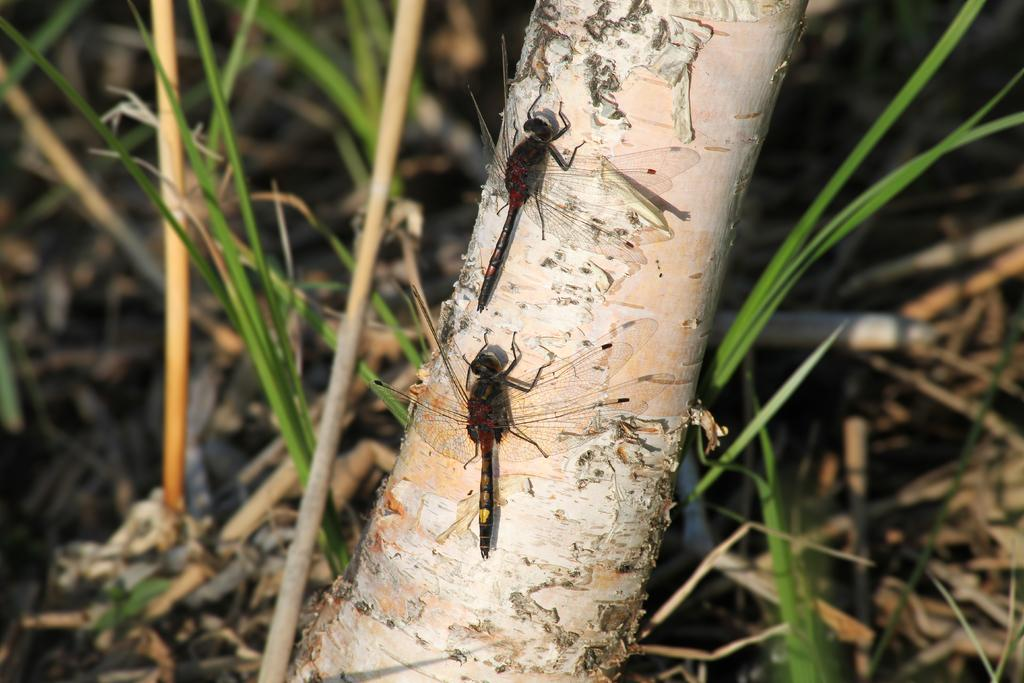What type of creatures can be seen on the tree trunk in the image? There are two insects on a tree trunk in the image. What type of vegetation is visible in the background of the image? There is grass visible in the background of the image. What type of shame can be seen on the insects' faces in the image? There is no indication of shame or any facial expressions on the insects in the image. How many quarters are visible in the image? There are no quarters present in the image. 